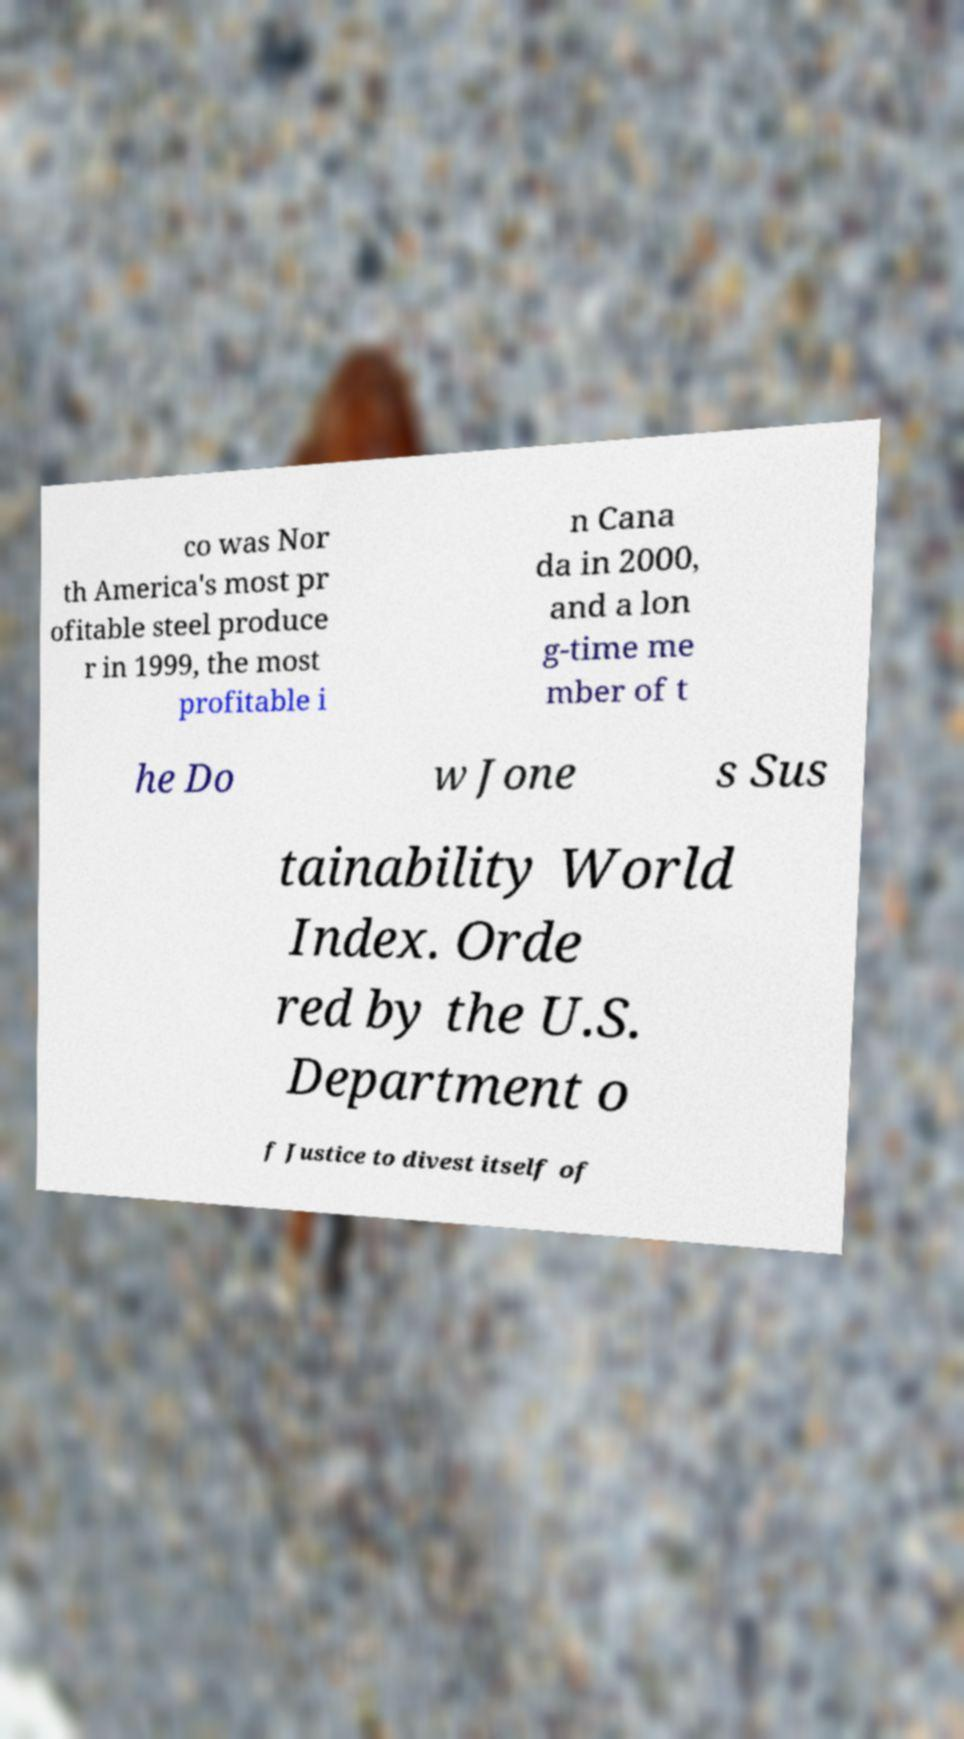Could you extract and type out the text from this image? co was Nor th America's most pr ofitable steel produce r in 1999, the most profitable i n Cana da in 2000, and a lon g-time me mber of t he Do w Jone s Sus tainability World Index. Orde red by the U.S. Department o f Justice to divest itself of 